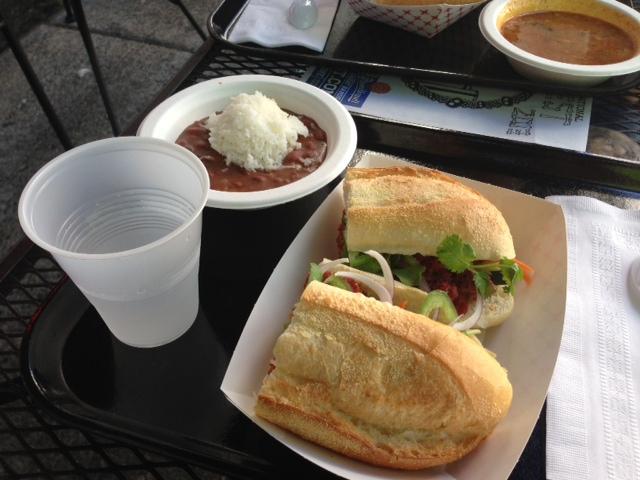How many trays of food are there?
Short answer required. 2. Is this meal at a fast food restaurant?
Quick response, please. Yes. How many cups of drinks are there?
Keep it brief. 1. 